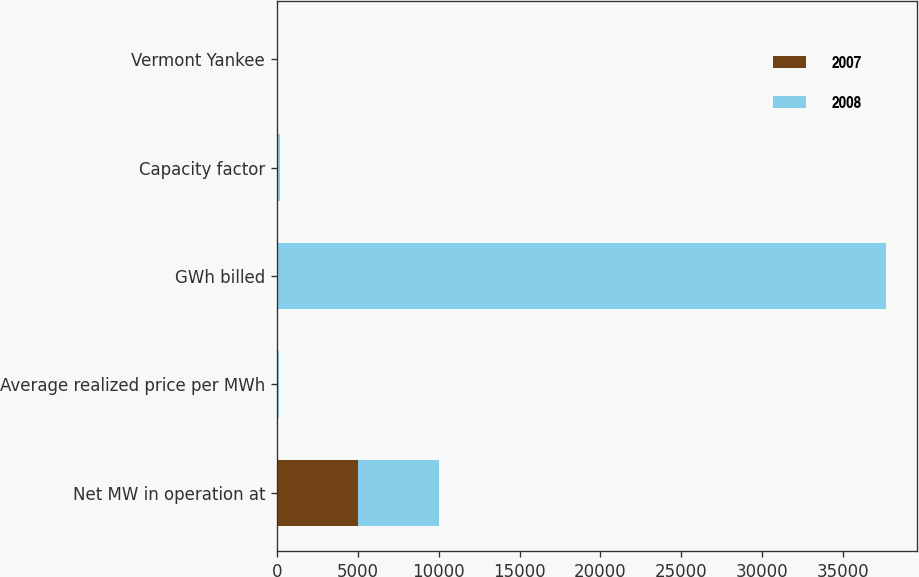<chart> <loc_0><loc_0><loc_500><loc_500><stacked_bar_chart><ecel><fcel>Net MW in operation at<fcel>Average realized price per MWh<fcel>GWh billed<fcel>Capacity factor<fcel>Vermont Yankee<nl><fcel>2007<fcel>4998<fcel>59.51<fcel>89<fcel>95<fcel>22<nl><fcel>2008<fcel>4998<fcel>52.69<fcel>37570<fcel>89<fcel>24<nl></chart> 